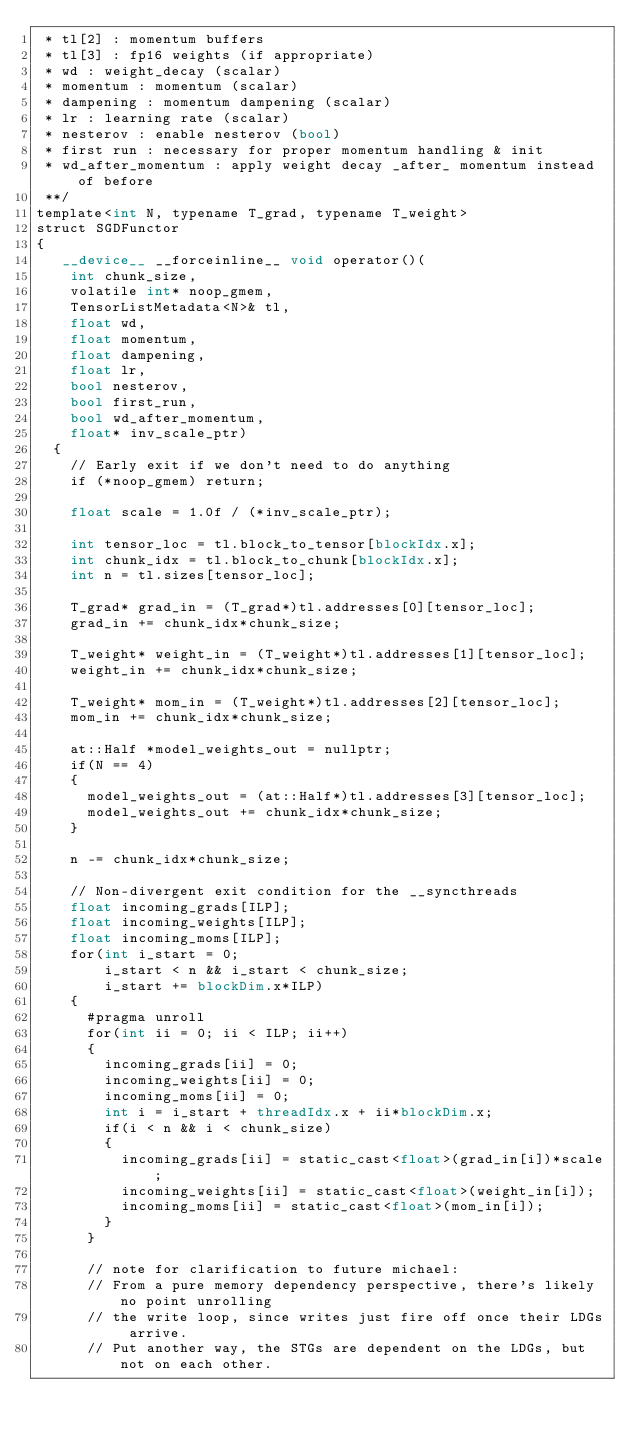Convert code to text. <code><loc_0><loc_0><loc_500><loc_500><_Cuda_> * tl[2] : momentum buffers
 * tl[3] : fp16 weights (if appropriate)
 * wd : weight_decay (scalar)
 * momentum : momentum (scalar)
 * dampening : momentum dampening (scalar)
 * lr : learning rate (scalar)
 * nesterov : enable nesterov (bool)
 * first run : necessary for proper momentum handling & init
 * wd_after_momentum : apply weight decay _after_ momentum instead of before
 **/
template<int N, typename T_grad, typename T_weight>
struct SGDFunctor
{
   __device__ __forceinline__ void operator()(
    int chunk_size,
    volatile int* noop_gmem,
    TensorListMetadata<N>& tl,
    float wd,
    float momentum,
    float dampening,
    float lr,
    bool nesterov,
    bool first_run,
    bool wd_after_momentum,
    float* inv_scale_ptr)
  {
    // Early exit if we don't need to do anything
    if (*noop_gmem) return;

    float scale = 1.0f / (*inv_scale_ptr);

    int tensor_loc = tl.block_to_tensor[blockIdx.x];
    int chunk_idx = tl.block_to_chunk[blockIdx.x];
    int n = tl.sizes[tensor_loc];

    T_grad* grad_in = (T_grad*)tl.addresses[0][tensor_loc];
    grad_in += chunk_idx*chunk_size;

    T_weight* weight_in = (T_weight*)tl.addresses[1][tensor_loc];
    weight_in += chunk_idx*chunk_size;

    T_weight* mom_in = (T_weight*)tl.addresses[2][tensor_loc];
    mom_in += chunk_idx*chunk_size;

    at::Half *model_weights_out = nullptr;
    if(N == 4)
    {
      model_weights_out = (at::Half*)tl.addresses[3][tensor_loc];
      model_weights_out += chunk_idx*chunk_size;
    }

    n -= chunk_idx*chunk_size;

    // Non-divergent exit condition for the __syncthreads
    float incoming_grads[ILP];
    float incoming_weights[ILP];
    float incoming_moms[ILP];
    for(int i_start = 0;
        i_start < n && i_start < chunk_size;
        i_start += blockDim.x*ILP)
    {
      #pragma unroll
      for(int ii = 0; ii < ILP; ii++)
      {
        incoming_grads[ii] = 0;
        incoming_weights[ii] = 0;
        incoming_moms[ii] = 0;
        int i = i_start + threadIdx.x + ii*blockDim.x;
        if(i < n && i < chunk_size)
        {
          incoming_grads[ii] = static_cast<float>(grad_in[i])*scale;
          incoming_weights[ii] = static_cast<float>(weight_in[i]);
          incoming_moms[ii] = static_cast<float>(mom_in[i]);
        }
      }

      // note for clarification to future michael:
      // From a pure memory dependency perspective, there's likely no point unrolling
      // the write loop, since writes just fire off once their LDGs arrive.
      // Put another way, the STGs are dependent on the LDGs, but not on each other.</code> 